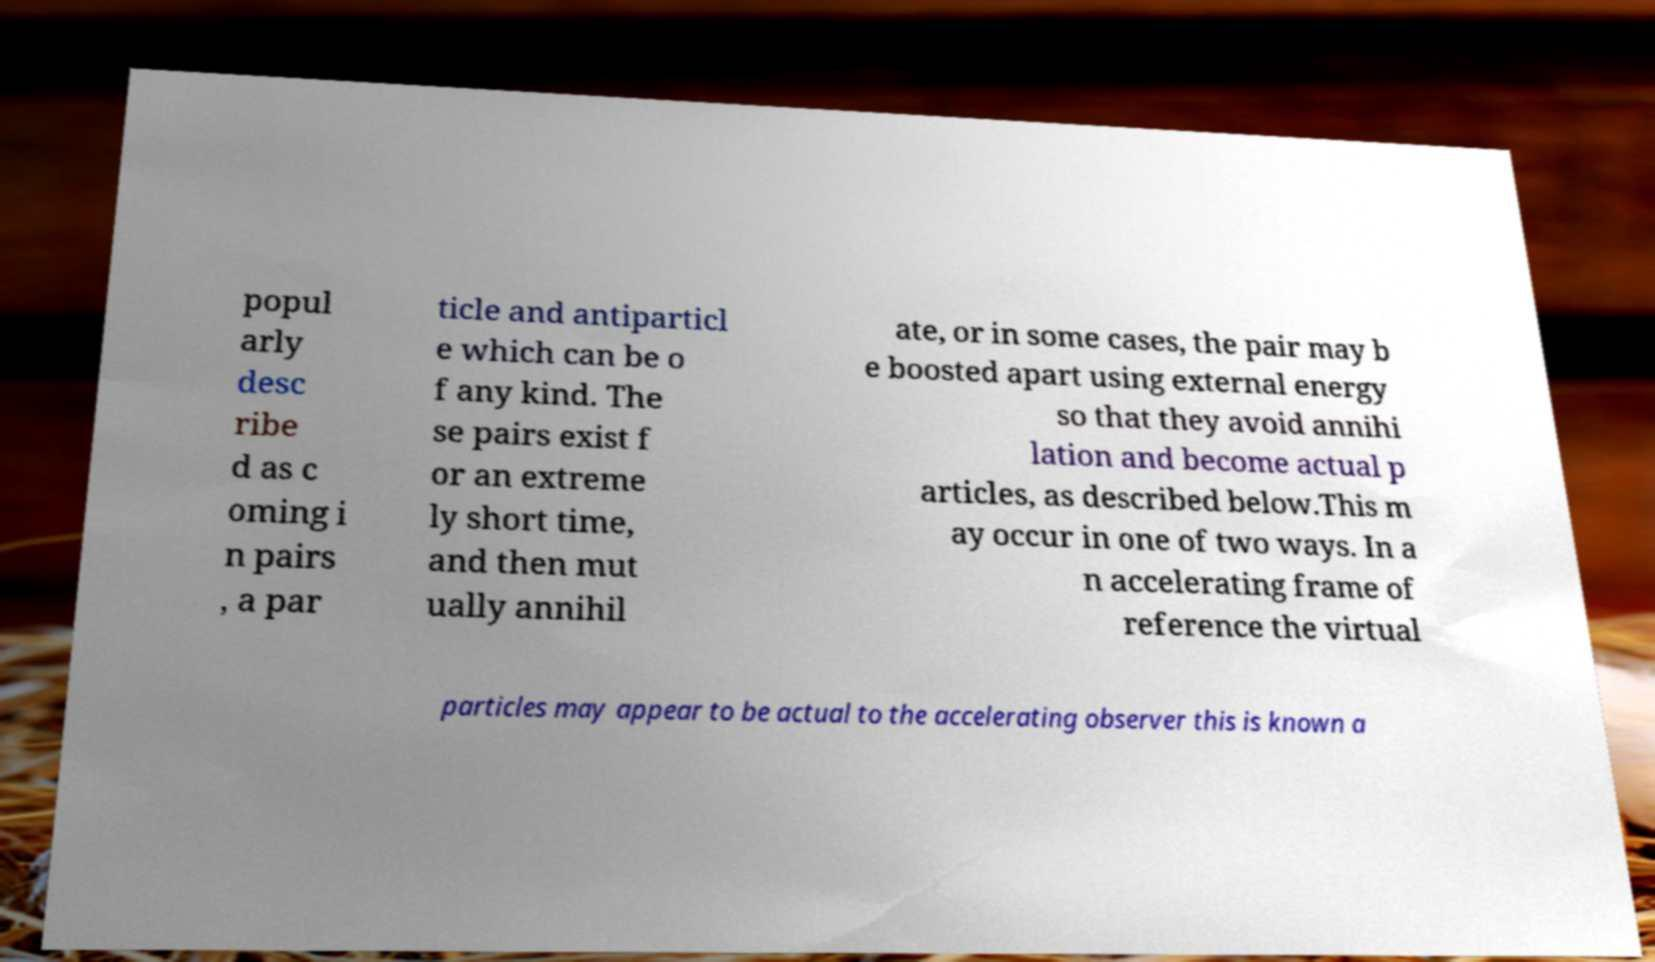For documentation purposes, I need the text within this image transcribed. Could you provide that? popul arly desc ribe d as c oming i n pairs , a par ticle and antiparticl e which can be o f any kind. The se pairs exist f or an extreme ly short time, and then mut ually annihil ate, or in some cases, the pair may b e boosted apart using external energy so that they avoid annihi lation and become actual p articles, as described below.This m ay occur in one of two ways. In a n accelerating frame of reference the virtual particles may appear to be actual to the accelerating observer this is known a 